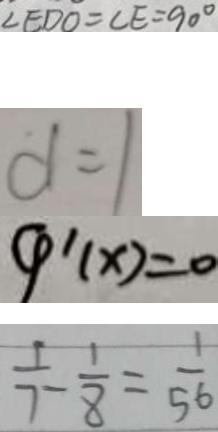<formula> <loc_0><loc_0><loc_500><loc_500>\angle E D O = \angle E = 9 0 ^ { \circ } 
 d = 1 
 4 ^ { \prime } ( x ) = 0 
 \frac { 1 } { 7 } - \frac { 1 } { 8 } = \frac { 1 } { 5 6 }</formula> 